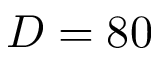<formula> <loc_0><loc_0><loc_500><loc_500>D = 8 0</formula> 